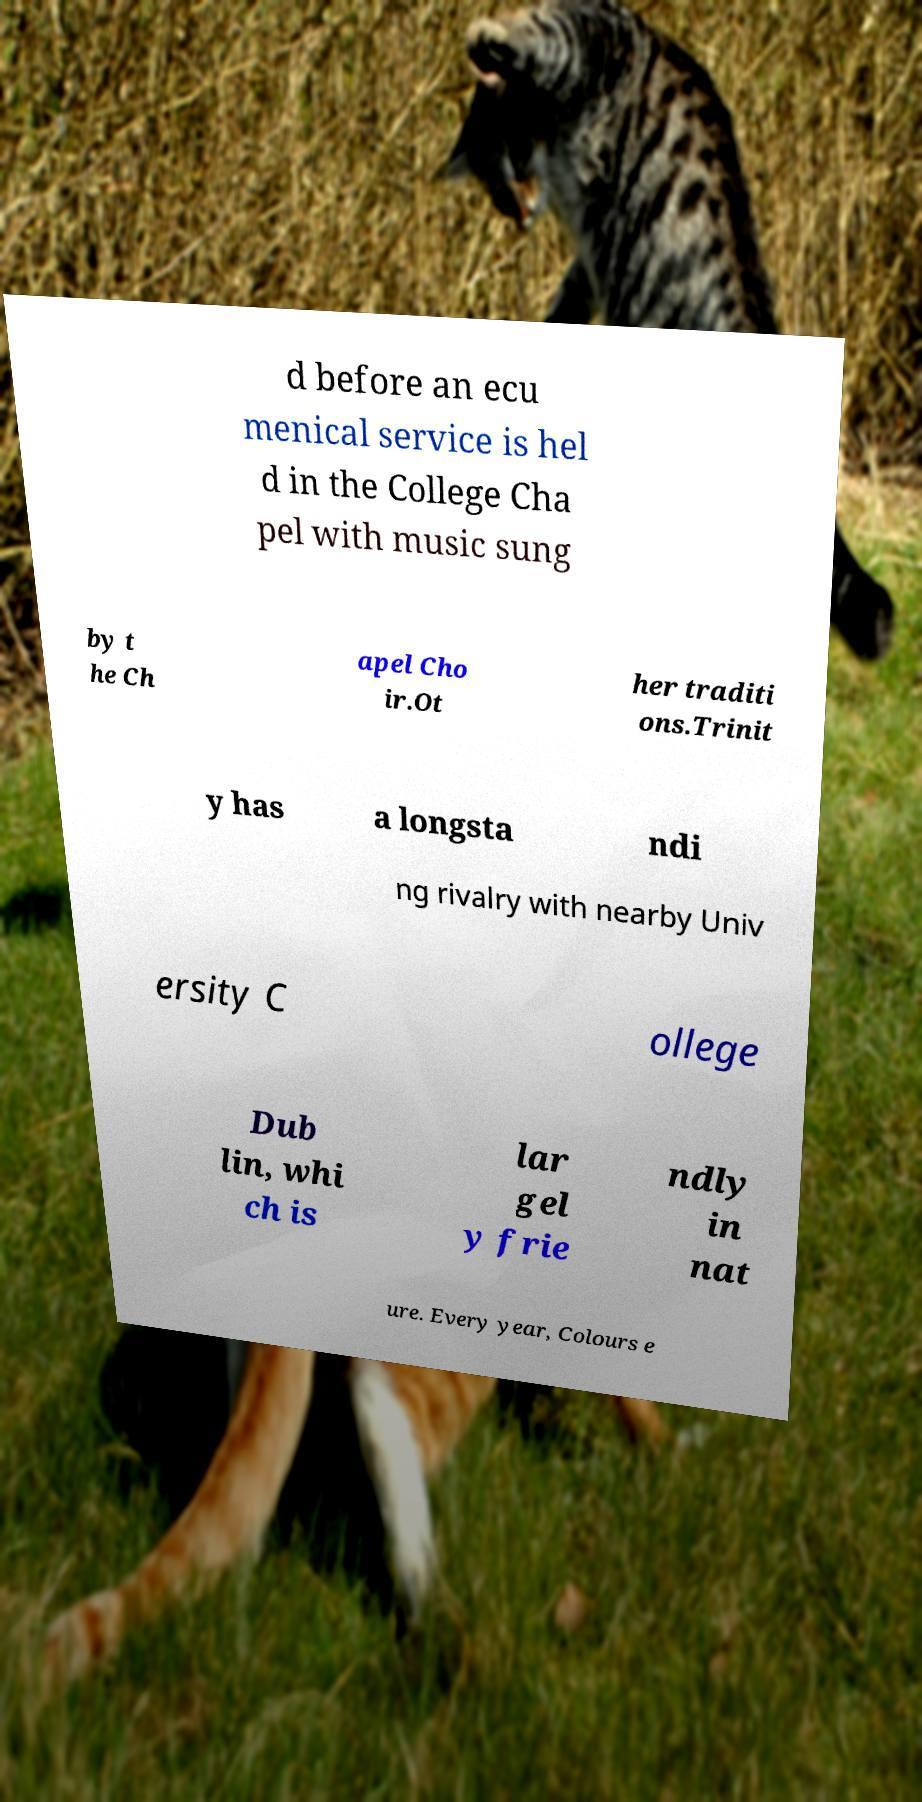I need the written content from this picture converted into text. Can you do that? d before an ecu menical service is hel d in the College Cha pel with music sung by t he Ch apel Cho ir.Ot her traditi ons.Trinit y has a longsta ndi ng rivalry with nearby Univ ersity C ollege Dub lin, whi ch is lar gel y frie ndly in nat ure. Every year, Colours e 